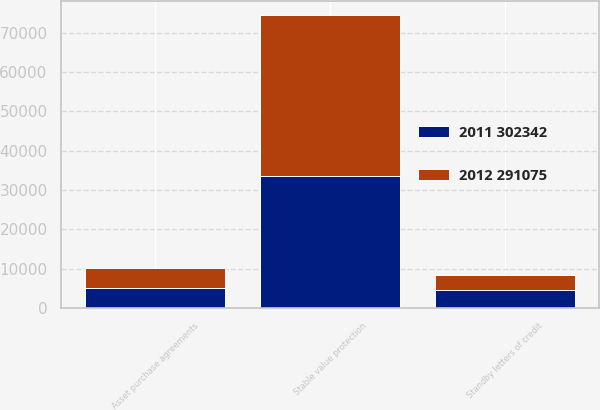Convert chart. <chart><loc_0><loc_0><loc_500><loc_500><stacked_bar_chart><ecel><fcel>Stable value protection<fcel>Asset purchase agreements<fcel>Standby letters of credit<nl><fcel>2011 302342<fcel>33512<fcel>5063<fcel>4552<nl><fcel>2012 291075<fcel>40963<fcel>5056<fcel>3938<nl></chart> 